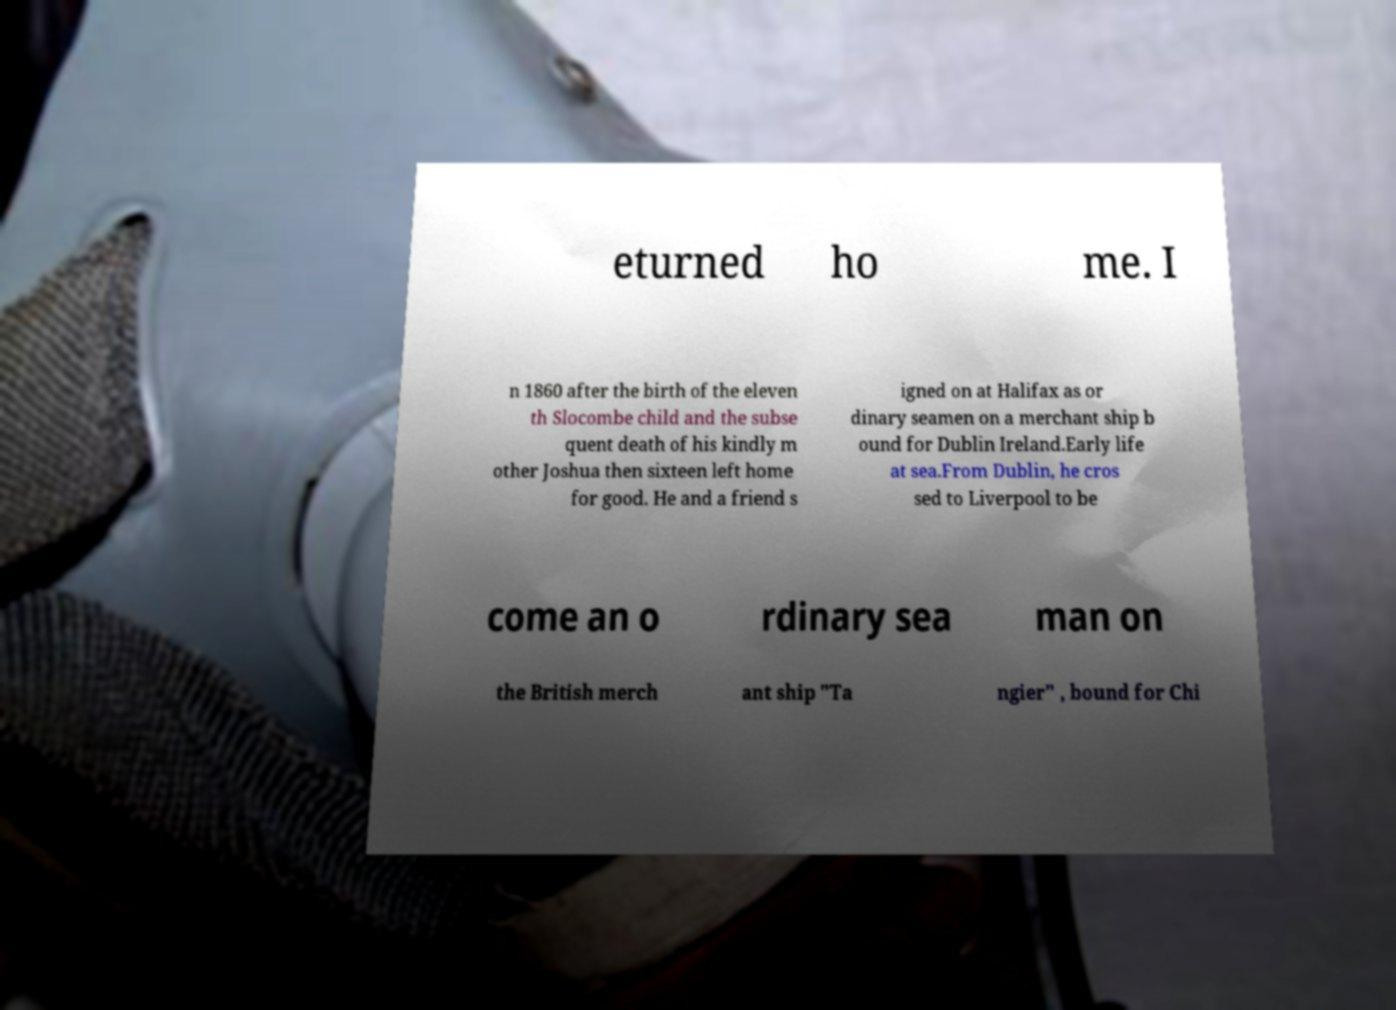Could you assist in decoding the text presented in this image and type it out clearly? eturned ho me. I n 1860 after the birth of the eleven th Slocombe child and the subse quent death of his kindly m other Joshua then sixteen left home for good. He and a friend s igned on at Halifax as or dinary seamen on a merchant ship b ound for Dublin Ireland.Early life at sea.From Dublin, he cros sed to Liverpool to be come an o rdinary sea man on the British merch ant ship "Ta ngier" , bound for Chi 